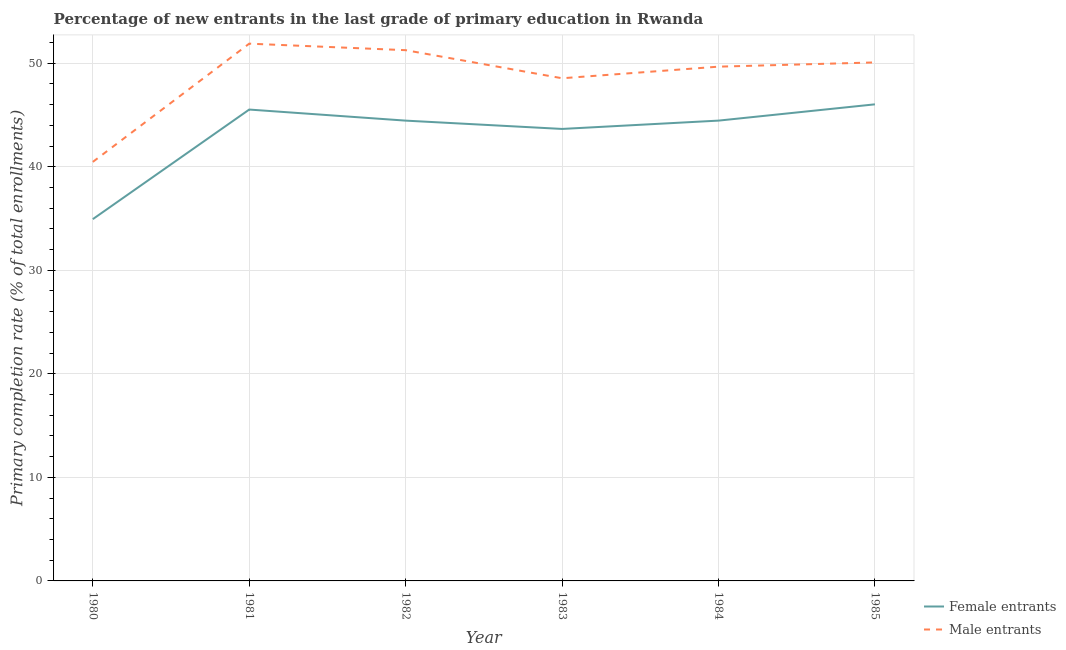How many different coloured lines are there?
Offer a very short reply. 2. Does the line corresponding to primary completion rate of male entrants intersect with the line corresponding to primary completion rate of female entrants?
Keep it short and to the point. No. What is the primary completion rate of male entrants in 1981?
Your response must be concise. 51.88. Across all years, what is the maximum primary completion rate of male entrants?
Ensure brevity in your answer.  51.88. Across all years, what is the minimum primary completion rate of male entrants?
Provide a succinct answer. 40.47. In which year was the primary completion rate of female entrants maximum?
Ensure brevity in your answer.  1985. What is the total primary completion rate of male entrants in the graph?
Provide a short and direct response. 291.88. What is the difference between the primary completion rate of female entrants in 1980 and that in 1984?
Provide a short and direct response. -9.51. What is the difference between the primary completion rate of female entrants in 1982 and the primary completion rate of male entrants in 1984?
Keep it short and to the point. -5.21. What is the average primary completion rate of male entrants per year?
Your answer should be very brief. 48.65. In the year 1980, what is the difference between the primary completion rate of male entrants and primary completion rate of female entrants?
Ensure brevity in your answer.  5.53. In how many years, is the primary completion rate of female entrants greater than 26 %?
Your answer should be very brief. 6. What is the ratio of the primary completion rate of male entrants in 1982 to that in 1985?
Provide a short and direct response. 1.02. Is the primary completion rate of female entrants in 1980 less than that in 1982?
Your answer should be very brief. Yes. What is the difference between the highest and the second highest primary completion rate of female entrants?
Provide a succinct answer. 0.5. What is the difference between the highest and the lowest primary completion rate of female entrants?
Ensure brevity in your answer.  11.09. In how many years, is the primary completion rate of female entrants greater than the average primary completion rate of female entrants taken over all years?
Your answer should be very brief. 5. Is the sum of the primary completion rate of male entrants in 1983 and 1985 greater than the maximum primary completion rate of female entrants across all years?
Make the answer very short. Yes. Does the primary completion rate of male entrants monotonically increase over the years?
Provide a succinct answer. No. Is the primary completion rate of female entrants strictly greater than the primary completion rate of male entrants over the years?
Ensure brevity in your answer.  No. How many lines are there?
Your answer should be compact. 2. Does the graph contain any zero values?
Keep it short and to the point. No. How are the legend labels stacked?
Offer a very short reply. Vertical. What is the title of the graph?
Your answer should be compact. Percentage of new entrants in the last grade of primary education in Rwanda. What is the label or title of the Y-axis?
Offer a very short reply. Primary completion rate (% of total enrollments). What is the Primary completion rate (% of total enrollments) in Female entrants in 1980?
Keep it short and to the point. 34.94. What is the Primary completion rate (% of total enrollments) in Male entrants in 1980?
Provide a succinct answer. 40.47. What is the Primary completion rate (% of total enrollments) in Female entrants in 1981?
Offer a terse response. 45.52. What is the Primary completion rate (% of total enrollments) of Male entrants in 1981?
Your answer should be very brief. 51.88. What is the Primary completion rate (% of total enrollments) in Female entrants in 1982?
Your response must be concise. 44.45. What is the Primary completion rate (% of total enrollments) of Male entrants in 1982?
Your answer should be compact. 51.25. What is the Primary completion rate (% of total enrollments) in Female entrants in 1983?
Ensure brevity in your answer.  43.65. What is the Primary completion rate (% of total enrollments) in Male entrants in 1983?
Give a very brief answer. 48.54. What is the Primary completion rate (% of total enrollments) of Female entrants in 1984?
Provide a short and direct response. 44.45. What is the Primary completion rate (% of total enrollments) in Male entrants in 1984?
Your response must be concise. 49.66. What is the Primary completion rate (% of total enrollments) of Female entrants in 1985?
Offer a very short reply. 46.02. What is the Primary completion rate (% of total enrollments) in Male entrants in 1985?
Provide a short and direct response. 50.07. Across all years, what is the maximum Primary completion rate (% of total enrollments) in Female entrants?
Your answer should be compact. 46.02. Across all years, what is the maximum Primary completion rate (% of total enrollments) of Male entrants?
Ensure brevity in your answer.  51.88. Across all years, what is the minimum Primary completion rate (% of total enrollments) in Female entrants?
Your answer should be compact. 34.94. Across all years, what is the minimum Primary completion rate (% of total enrollments) in Male entrants?
Keep it short and to the point. 40.47. What is the total Primary completion rate (% of total enrollments) of Female entrants in the graph?
Ensure brevity in your answer.  259.03. What is the total Primary completion rate (% of total enrollments) of Male entrants in the graph?
Ensure brevity in your answer.  291.88. What is the difference between the Primary completion rate (% of total enrollments) in Female entrants in 1980 and that in 1981?
Keep it short and to the point. -10.58. What is the difference between the Primary completion rate (% of total enrollments) in Male entrants in 1980 and that in 1981?
Offer a very short reply. -11.42. What is the difference between the Primary completion rate (% of total enrollments) of Female entrants in 1980 and that in 1982?
Your answer should be compact. -9.51. What is the difference between the Primary completion rate (% of total enrollments) of Male entrants in 1980 and that in 1982?
Make the answer very short. -10.79. What is the difference between the Primary completion rate (% of total enrollments) in Female entrants in 1980 and that in 1983?
Keep it short and to the point. -8.71. What is the difference between the Primary completion rate (% of total enrollments) in Male entrants in 1980 and that in 1983?
Offer a terse response. -8.08. What is the difference between the Primary completion rate (% of total enrollments) of Female entrants in 1980 and that in 1984?
Give a very brief answer. -9.51. What is the difference between the Primary completion rate (% of total enrollments) in Male entrants in 1980 and that in 1984?
Your answer should be compact. -9.2. What is the difference between the Primary completion rate (% of total enrollments) in Female entrants in 1980 and that in 1985?
Offer a terse response. -11.09. What is the difference between the Primary completion rate (% of total enrollments) in Male entrants in 1980 and that in 1985?
Provide a short and direct response. -9.61. What is the difference between the Primary completion rate (% of total enrollments) of Female entrants in 1981 and that in 1982?
Offer a terse response. 1.07. What is the difference between the Primary completion rate (% of total enrollments) in Male entrants in 1981 and that in 1982?
Ensure brevity in your answer.  0.63. What is the difference between the Primary completion rate (% of total enrollments) of Female entrants in 1981 and that in 1983?
Your response must be concise. 1.87. What is the difference between the Primary completion rate (% of total enrollments) of Male entrants in 1981 and that in 1983?
Offer a very short reply. 3.34. What is the difference between the Primary completion rate (% of total enrollments) of Female entrants in 1981 and that in 1984?
Provide a succinct answer. 1.07. What is the difference between the Primary completion rate (% of total enrollments) in Male entrants in 1981 and that in 1984?
Offer a very short reply. 2.22. What is the difference between the Primary completion rate (% of total enrollments) in Female entrants in 1981 and that in 1985?
Offer a terse response. -0.5. What is the difference between the Primary completion rate (% of total enrollments) of Male entrants in 1981 and that in 1985?
Provide a succinct answer. 1.81. What is the difference between the Primary completion rate (% of total enrollments) in Female entrants in 1982 and that in 1983?
Give a very brief answer. 0.8. What is the difference between the Primary completion rate (% of total enrollments) in Male entrants in 1982 and that in 1983?
Provide a succinct answer. 2.71. What is the difference between the Primary completion rate (% of total enrollments) in Female entrants in 1982 and that in 1984?
Your response must be concise. -0. What is the difference between the Primary completion rate (% of total enrollments) in Male entrants in 1982 and that in 1984?
Ensure brevity in your answer.  1.59. What is the difference between the Primary completion rate (% of total enrollments) in Female entrants in 1982 and that in 1985?
Keep it short and to the point. -1.57. What is the difference between the Primary completion rate (% of total enrollments) of Male entrants in 1982 and that in 1985?
Offer a very short reply. 1.18. What is the difference between the Primary completion rate (% of total enrollments) of Female entrants in 1983 and that in 1984?
Give a very brief answer. -0.8. What is the difference between the Primary completion rate (% of total enrollments) of Male entrants in 1983 and that in 1984?
Offer a terse response. -1.12. What is the difference between the Primary completion rate (% of total enrollments) in Female entrants in 1983 and that in 1985?
Your response must be concise. -2.38. What is the difference between the Primary completion rate (% of total enrollments) in Male entrants in 1983 and that in 1985?
Ensure brevity in your answer.  -1.53. What is the difference between the Primary completion rate (% of total enrollments) in Female entrants in 1984 and that in 1985?
Your answer should be compact. -1.57. What is the difference between the Primary completion rate (% of total enrollments) in Male entrants in 1984 and that in 1985?
Give a very brief answer. -0.41. What is the difference between the Primary completion rate (% of total enrollments) of Female entrants in 1980 and the Primary completion rate (% of total enrollments) of Male entrants in 1981?
Offer a terse response. -16.95. What is the difference between the Primary completion rate (% of total enrollments) in Female entrants in 1980 and the Primary completion rate (% of total enrollments) in Male entrants in 1982?
Your answer should be compact. -16.32. What is the difference between the Primary completion rate (% of total enrollments) of Female entrants in 1980 and the Primary completion rate (% of total enrollments) of Male entrants in 1983?
Give a very brief answer. -13.6. What is the difference between the Primary completion rate (% of total enrollments) in Female entrants in 1980 and the Primary completion rate (% of total enrollments) in Male entrants in 1984?
Offer a terse response. -14.72. What is the difference between the Primary completion rate (% of total enrollments) in Female entrants in 1980 and the Primary completion rate (% of total enrollments) in Male entrants in 1985?
Offer a very short reply. -15.13. What is the difference between the Primary completion rate (% of total enrollments) in Female entrants in 1981 and the Primary completion rate (% of total enrollments) in Male entrants in 1982?
Ensure brevity in your answer.  -5.73. What is the difference between the Primary completion rate (% of total enrollments) of Female entrants in 1981 and the Primary completion rate (% of total enrollments) of Male entrants in 1983?
Your response must be concise. -3.02. What is the difference between the Primary completion rate (% of total enrollments) in Female entrants in 1981 and the Primary completion rate (% of total enrollments) in Male entrants in 1984?
Your response must be concise. -4.14. What is the difference between the Primary completion rate (% of total enrollments) in Female entrants in 1981 and the Primary completion rate (% of total enrollments) in Male entrants in 1985?
Keep it short and to the point. -4.55. What is the difference between the Primary completion rate (% of total enrollments) of Female entrants in 1982 and the Primary completion rate (% of total enrollments) of Male entrants in 1983?
Your answer should be very brief. -4.09. What is the difference between the Primary completion rate (% of total enrollments) in Female entrants in 1982 and the Primary completion rate (% of total enrollments) in Male entrants in 1984?
Ensure brevity in your answer.  -5.21. What is the difference between the Primary completion rate (% of total enrollments) in Female entrants in 1982 and the Primary completion rate (% of total enrollments) in Male entrants in 1985?
Provide a succinct answer. -5.62. What is the difference between the Primary completion rate (% of total enrollments) of Female entrants in 1983 and the Primary completion rate (% of total enrollments) of Male entrants in 1984?
Offer a very short reply. -6.01. What is the difference between the Primary completion rate (% of total enrollments) in Female entrants in 1983 and the Primary completion rate (% of total enrollments) in Male entrants in 1985?
Keep it short and to the point. -6.42. What is the difference between the Primary completion rate (% of total enrollments) in Female entrants in 1984 and the Primary completion rate (% of total enrollments) in Male entrants in 1985?
Your answer should be compact. -5.62. What is the average Primary completion rate (% of total enrollments) in Female entrants per year?
Make the answer very short. 43.17. What is the average Primary completion rate (% of total enrollments) in Male entrants per year?
Give a very brief answer. 48.65. In the year 1980, what is the difference between the Primary completion rate (% of total enrollments) in Female entrants and Primary completion rate (% of total enrollments) in Male entrants?
Your answer should be compact. -5.53. In the year 1981, what is the difference between the Primary completion rate (% of total enrollments) of Female entrants and Primary completion rate (% of total enrollments) of Male entrants?
Offer a terse response. -6.36. In the year 1982, what is the difference between the Primary completion rate (% of total enrollments) of Female entrants and Primary completion rate (% of total enrollments) of Male entrants?
Provide a short and direct response. -6.8. In the year 1983, what is the difference between the Primary completion rate (% of total enrollments) of Female entrants and Primary completion rate (% of total enrollments) of Male entrants?
Your answer should be compact. -4.89. In the year 1984, what is the difference between the Primary completion rate (% of total enrollments) in Female entrants and Primary completion rate (% of total enrollments) in Male entrants?
Provide a short and direct response. -5.21. In the year 1985, what is the difference between the Primary completion rate (% of total enrollments) of Female entrants and Primary completion rate (% of total enrollments) of Male entrants?
Offer a very short reply. -4.05. What is the ratio of the Primary completion rate (% of total enrollments) in Female entrants in 1980 to that in 1981?
Ensure brevity in your answer.  0.77. What is the ratio of the Primary completion rate (% of total enrollments) in Male entrants in 1980 to that in 1981?
Your answer should be very brief. 0.78. What is the ratio of the Primary completion rate (% of total enrollments) of Female entrants in 1980 to that in 1982?
Make the answer very short. 0.79. What is the ratio of the Primary completion rate (% of total enrollments) in Male entrants in 1980 to that in 1982?
Your response must be concise. 0.79. What is the ratio of the Primary completion rate (% of total enrollments) in Female entrants in 1980 to that in 1983?
Offer a very short reply. 0.8. What is the ratio of the Primary completion rate (% of total enrollments) of Male entrants in 1980 to that in 1983?
Your answer should be compact. 0.83. What is the ratio of the Primary completion rate (% of total enrollments) in Female entrants in 1980 to that in 1984?
Keep it short and to the point. 0.79. What is the ratio of the Primary completion rate (% of total enrollments) in Male entrants in 1980 to that in 1984?
Make the answer very short. 0.81. What is the ratio of the Primary completion rate (% of total enrollments) in Female entrants in 1980 to that in 1985?
Provide a short and direct response. 0.76. What is the ratio of the Primary completion rate (% of total enrollments) in Male entrants in 1980 to that in 1985?
Keep it short and to the point. 0.81. What is the ratio of the Primary completion rate (% of total enrollments) in Male entrants in 1981 to that in 1982?
Ensure brevity in your answer.  1.01. What is the ratio of the Primary completion rate (% of total enrollments) in Female entrants in 1981 to that in 1983?
Give a very brief answer. 1.04. What is the ratio of the Primary completion rate (% of total enrollments) of Male entrants in 1981 to that in 1983?
Your response must be concise. 1.07. What is the ratio of the Primary completion rate (% of total enrollments) of Male entrants in 1981 to that in 1984?
Offer a terse response. 1.04. What is the ratio of the Primary completion rate (% of total enrollments) of Male entrants in 1981 to that in 1985?
Your answer should be very brief. 1.04. What is the ratio of the Primary completion rate (% of total enrollments) in Female entrants in 1982 to that in 1983?
Ensure brevity in your answer.  1.02. What is the ratio of the Primary completion rate (% of total enrollments) in Male entrants in 1982 to that in 1983?
Give a very brief answer. 1.06. What is the ratio of the Primary completion rate (% of total enrollments) in Female entrants in 1982 to that in 1984?
Make the answer very short. 1. What is the ratio of the Primary completion rate (% of total enrollments) in Male entrants in 1982 to that in 1984?
Your response must be concise. 1.03. What is the ratio of the Primary completion rate (% of total enrollments) in Female entrants in 1982 to that in 1985?
Your response must be concise. 0.97. What is the ratio of the Primary completion rate (% of total enrollments) in Male entrants in 1982 to that in 1985?
Offer a very short reply. 1.02. What is the ratio of the Primary completion rate (% of total enrollments) of Female entrants in 1983 to that in 1984?
Keep it short and to the point. 0.98. What is the ratio of the Primary completion rate (% of total enrollments) in Male entrants in 1983 to that in 1984?
Give a very brief answer. 0.98. What is the ratio of the Primary completion rate (% of total enrollments) in Female entrants in 1983 to that in 1985?
Your answer should be compact. 0.95. What is the ratio of the Primary completion rate (% of total enrollments) in Male entrants in 1983 to that in 1985?
Provide a short and direct response. 0.97. What is the ratio of the Primary completion rate (% of total enrollments) of Female entrants in 1984 to that in 1985?
Your answer should be compact. 0.97. What is the ratio of the Primary completion rate (% of total enrollments) in Male entrants in 1984 to that in 1985?
Provide a succinct answer. 0.99. What is the difference between the highest and the second highest Primary completion rate (% of total enrollments) in Female entrants?
Ensure brevity in your answer.  0.5. What is the difference between the highest and the second highest Primary completion rate (% of total enrollments) of Male entrants?
Make the answer very short. 0.63. What is the difference between the highest and the lowest Primary completion rate (% of total enrollments) of Female entrants?
Give a very brief answer. 11.09. What is the difference between the highest and the lowest Primary completion rate (% of total enrollments) of Male entrants?
Make the answer very short. 11.42. 